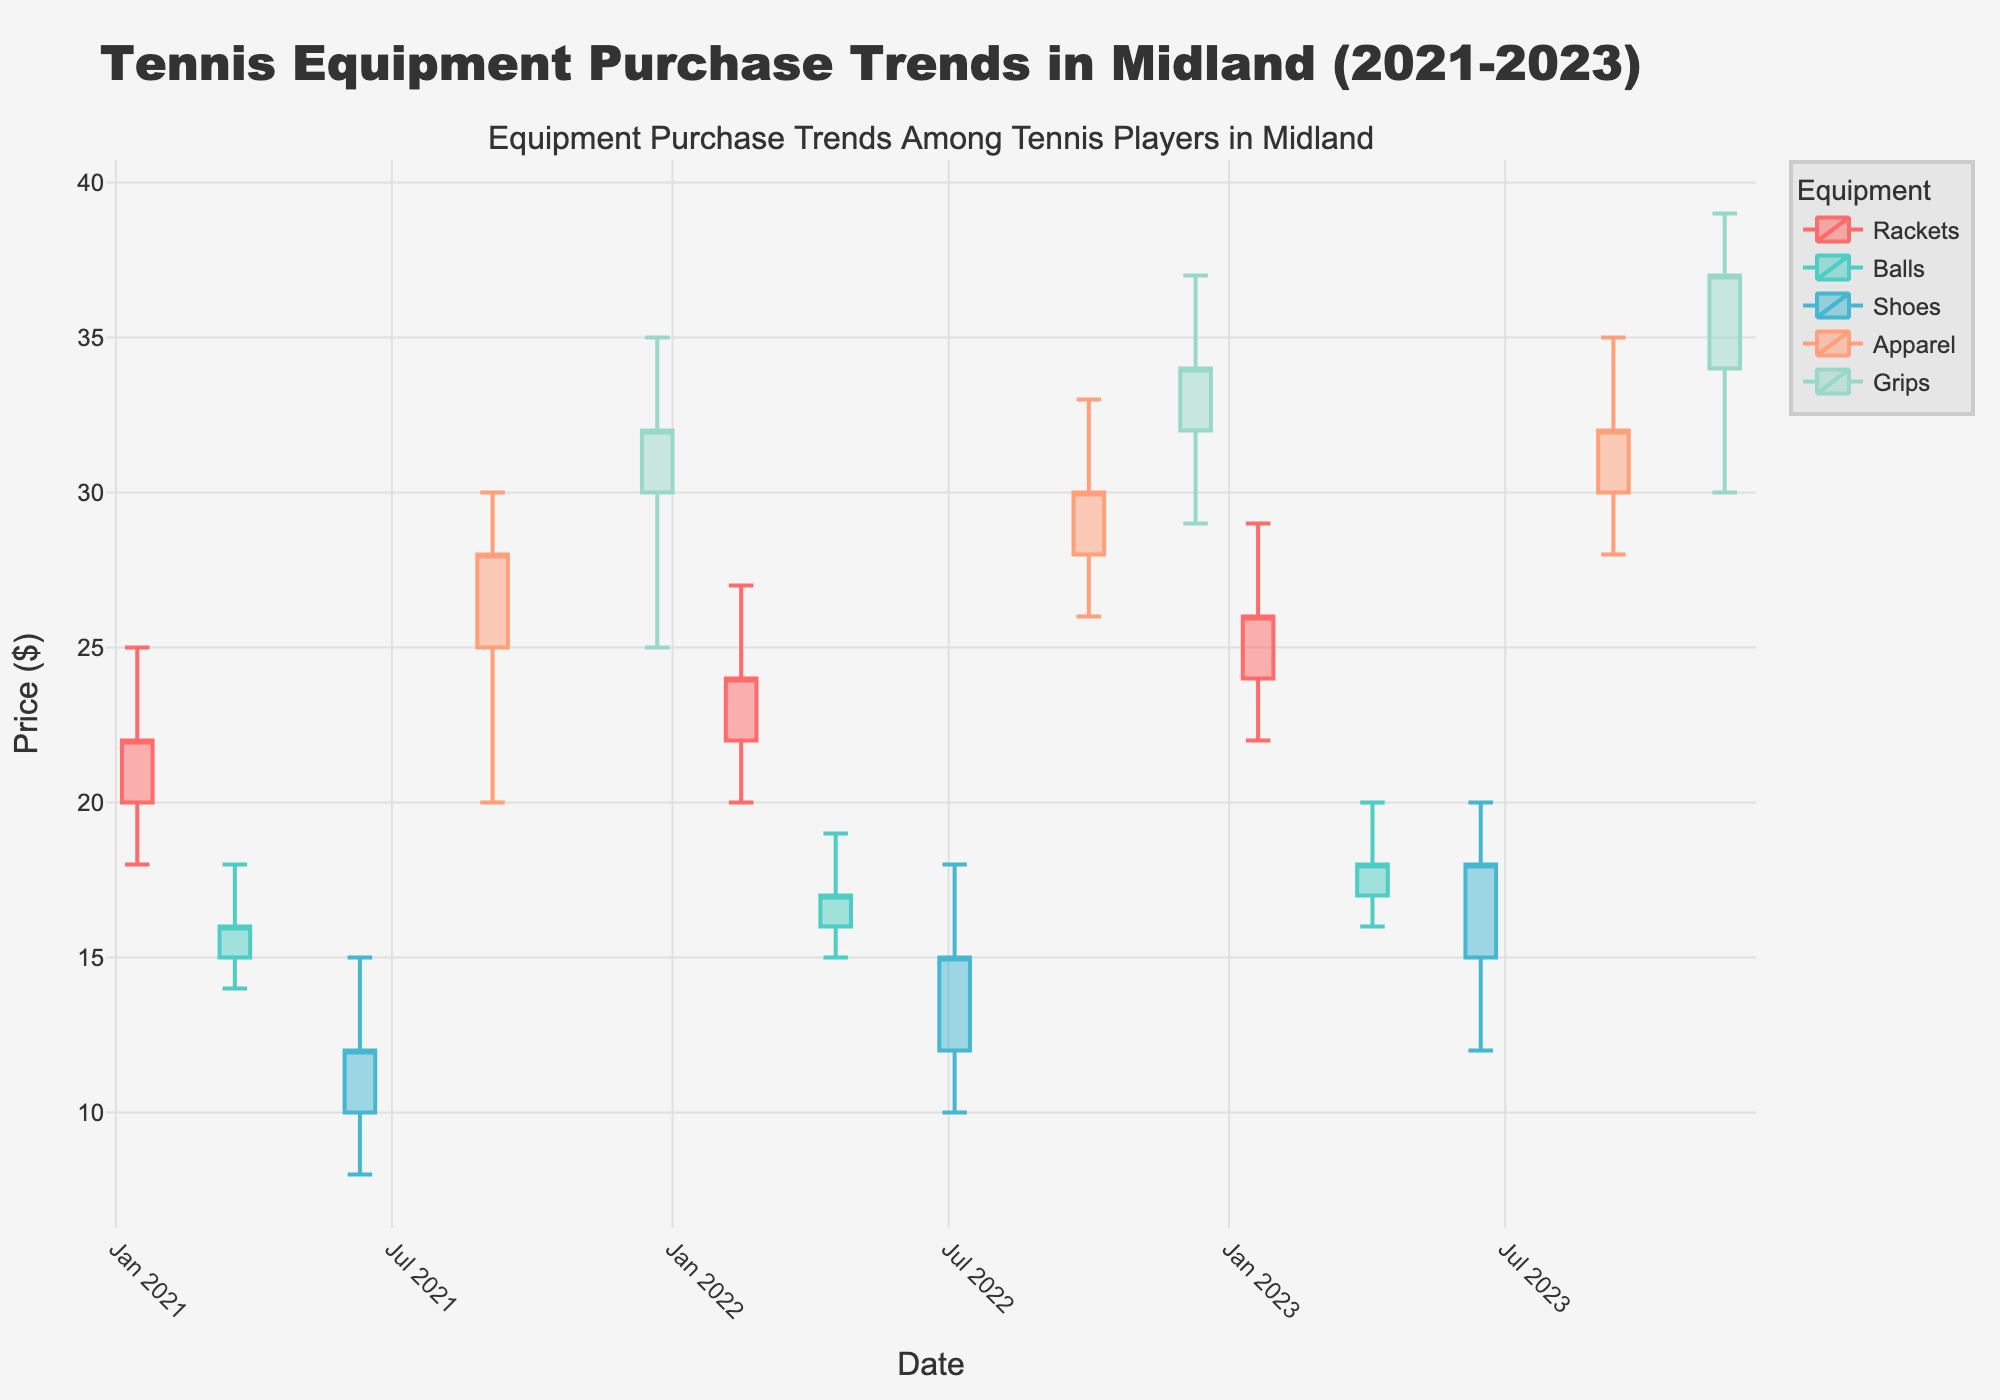What is the title of the plot? The title of the plot is displayed at the top of the figure. It reads "Tennis Equipment Purchase Trends in Midland (2021-2023)".
Answer: Tennis Equipment Purchase Trends in Midland (2021-2023) How many types of equipment are tracked in the plot? Look at the legend of the plot, which lists the types of equipment tracked. There are five items listed: rackets, balls, shoes, apparel, and grips.
Answer: Five Which type of equipment showed the highest price peak over the three years? Observe the high points in the candlestick plots for each item. The highest peak is in November 2023 for grips, at $39.
Answer: Grips Which equipment category had the lowest price point, and what was it? Find the lowest point on the candlestick plots for each item. Shoes reached the lowest price at $8 in June 2021.
Answer: Shoes $8 How did the close price for rackets change from January 2021 to January 2023? Observe the candlestick for rackets in January 2021 at $22 and in January 2023 at $26. Calculate $26 - $22.
Answer: Increased by $4 Which equipment had the most consistent price range over the last three years? Review each candlestick plot to see the range between the low and high points. The price range for balls, which varies between $14 and $20, seems the smallest.
Answer: Balls What was the closing price of apparel in September 2021 and in September 2023? Check the candlestick plot for apparel at these dates. In September 2021, the closing was $28, and in September 2023, it was $32.
Answer: $28 and $32 Compare the closing prices of grips from December 2021 to December 2022 to December 2023. What trend do you notice? Observe the closing prices of grips: December 2021 ($32), December 2022 ($34), December 2023 ($37). The prices have consistently increased.
Answer: Consistently increased In which quarter of which year did shoes experience the highest price? Check where the highest points occurred in the candlestick plots for shoes. The highest price for shoes was $20 in Q2 (June) 2023.
Answer: Q2 2023 What is the average closing price of shoes based on the given data? Add the closing prices for shoes ($12, $15, $18) and divide by the number of data points (3). The sum is $45, average is $45/3.
Answer: $15 